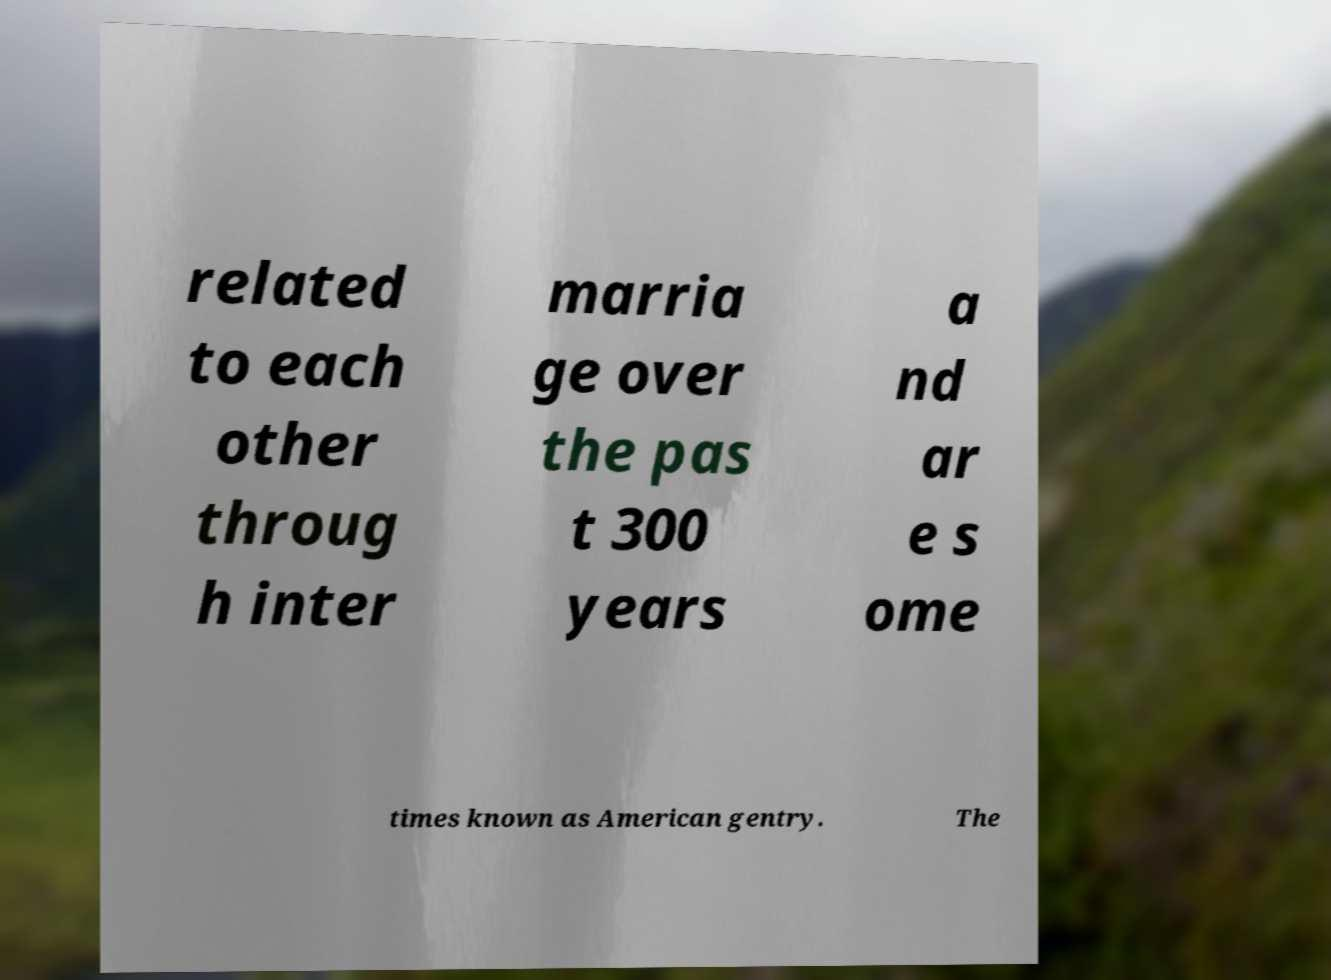Could you assist in decoding the text presented in this image and type it out clearly? related to each other throug h inter marria ge over the pas t 300 years a nd ar e s ome times known as American gentry. The 